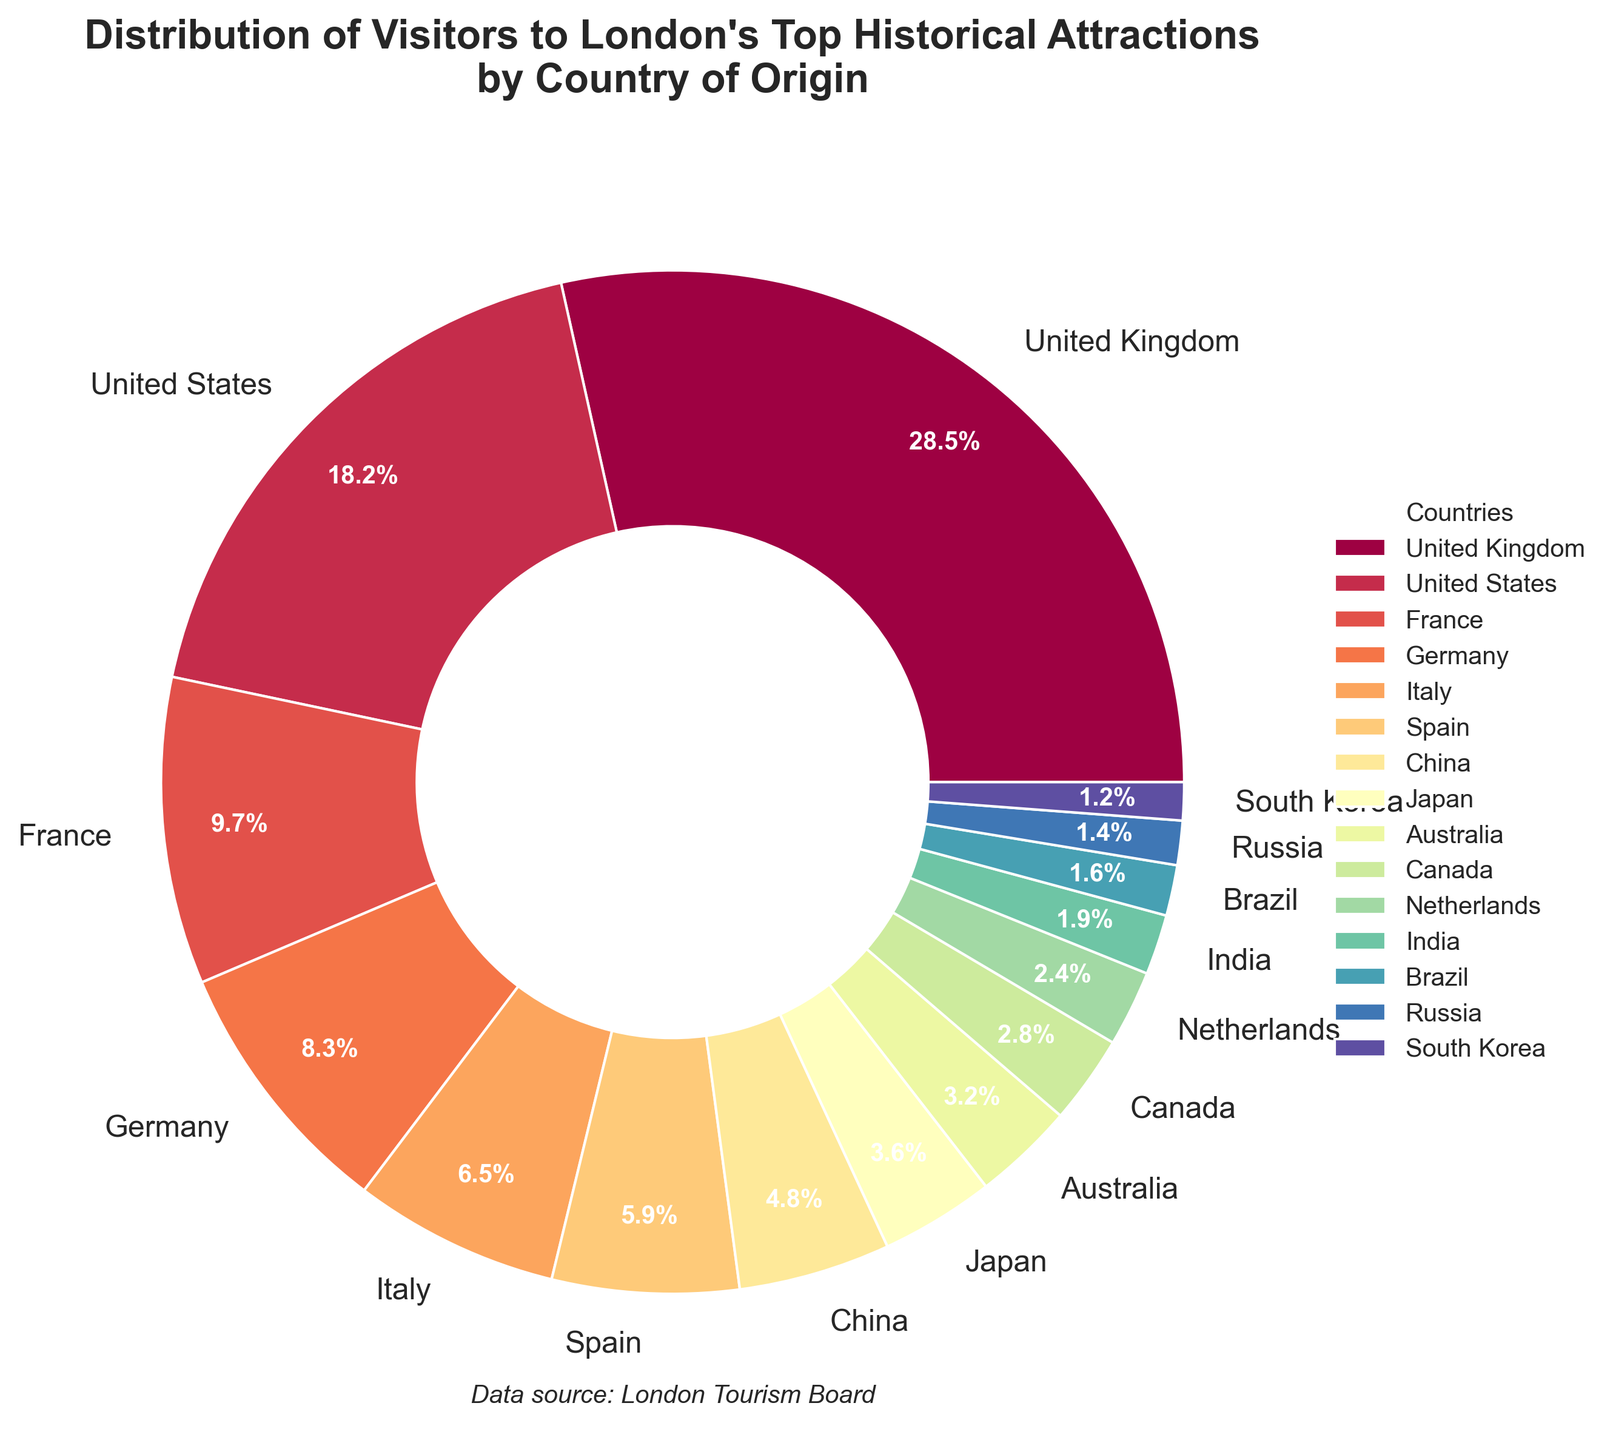What percentage of visitors are from the United States? To find the percentage of visitors from the United States, locate the corresponding wedge in the pie chart labeled "United States" and read the percentage displayed.
Answer: 18.2% Which country contributes the least to the visitors? Look for the smallest wedge in the pie chart and find the country label associated with it. The smallest percentage figure will be the one with 1.2%, which is South Korea.
Answer: South Korea Combine the percentages of visitors from the United Kingdom and Germany. What is the total? Add the percentage of visitors from the United Kingdom (28.5%) and Germany (8.3%) together: 28.5 + 8.3 = 36.8.
Answer: 36.8% Which has a higher visitor percentage: China or Japan? Compare the percentage values of China (4.8%) and Japan (3.6%). Since 4.8% is greater than 3.6%, China has a higher visitor percentage.
Answer: China How many countries contribute to less than 3% of the visitors each? Look for all wedges with percentages lower than 3%. These countries are Australia, Canada, Netherlands, India, Brazil, Russia, and South Korea. Count them up for a total: 7.
Answer: 7 What is the combined percentage of visitors from France, Italy, and Spain? Add the percentages of visitors from France (9.7%), Italy (6.5%), and Spain (5.9%). Sum these values: 9.7 + 6.5 + 5.9 = 22.1.
Answer: 22.1% Which country has the third-highest percentage of visitors? Rank the percentages from highest to lowest: UK (28.5%), US (18.2%), and France (9.7%). The third one listed is France.
Answer: France Are there more visitors from Canada or the Netherlands? Compare the percentage values of Canada (2.8%) and the Netherlands (2.4%). Since 2.8% is greater than 2.4%, Canada has more visitors.
Answer: Canada If you sum up the visitors from the United States, China, and Australia, what do you get? Add the percentages for the United States (18.2%), China (4.8%), and Australia (3.2%). The sum is 18.2 + 4.8 + 3.2 = 26.2.
Answer: 26.2% Compare the percentage of visitors from India and South Korea. Which percentage is higher and by how much? The percentage from India is 1.9% and from South Korea is 1.2%. Subtract the smaller percentage from the larger one: 1.9 - 1.2 = 0.7. The percentage from India is higher by 0.7%.
Answer: India by 0.7% 